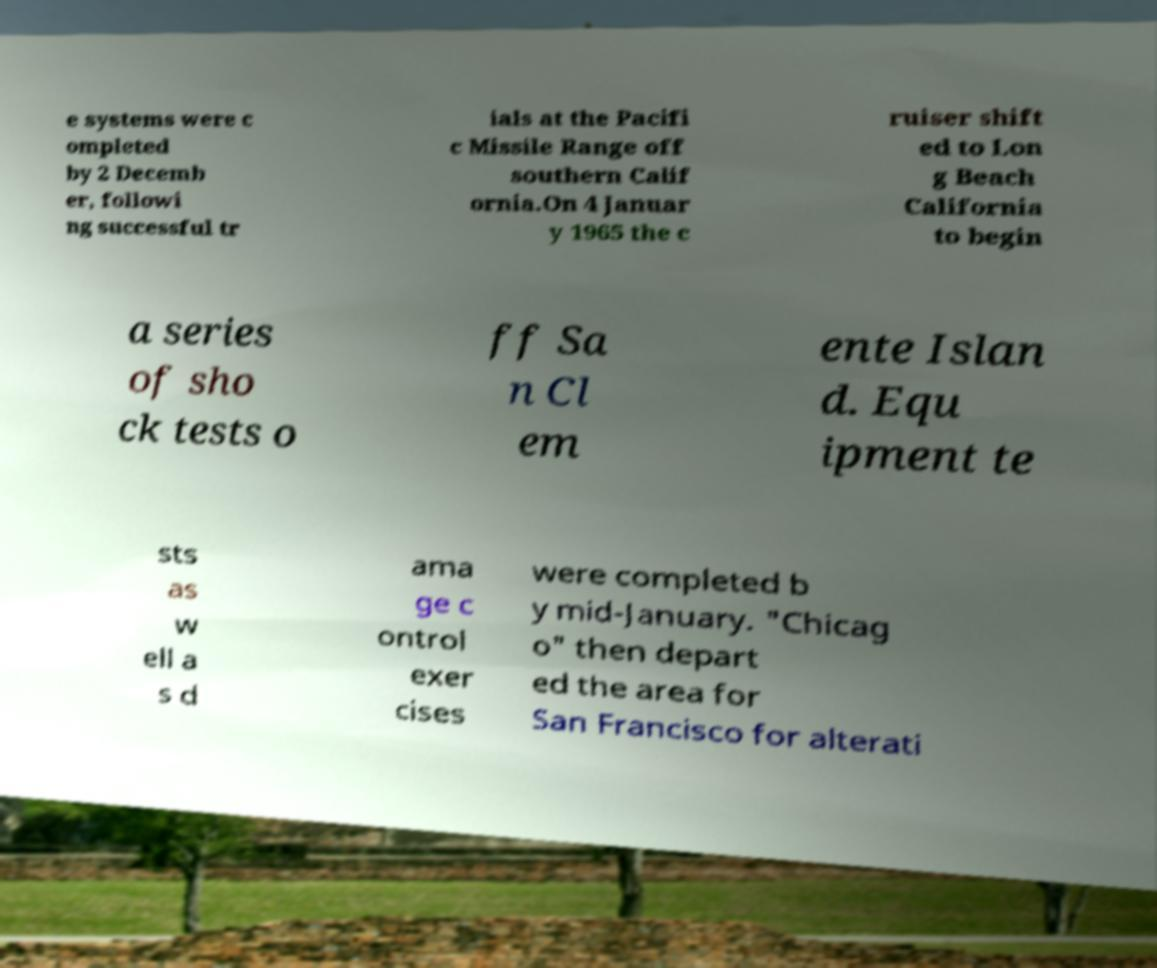Could you assist in decoding the text presented in this image and type it out clearly? e systems were c ompleted by 2 Decemb er, followi ng successful tr ials at the Pacifi c Missile Range off southern Calif ornia.On 4 Januar y 1965 the c ruiser shift ed to Lon g Beach California to begin a series of sho ck tests o ff Sa n Cl em ente Islan d. Equ ipment te sts as w ell a s d ama ge c ontrol exer cises were completed b y mid-January. "Chicag o" then depart ed the area for San Francisco for alterati 